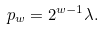<formula> <loc_0><loc_0><loc_500><loc_500>p _ { w } = 2 ^ { w - 1 } \lambda .</formula> 